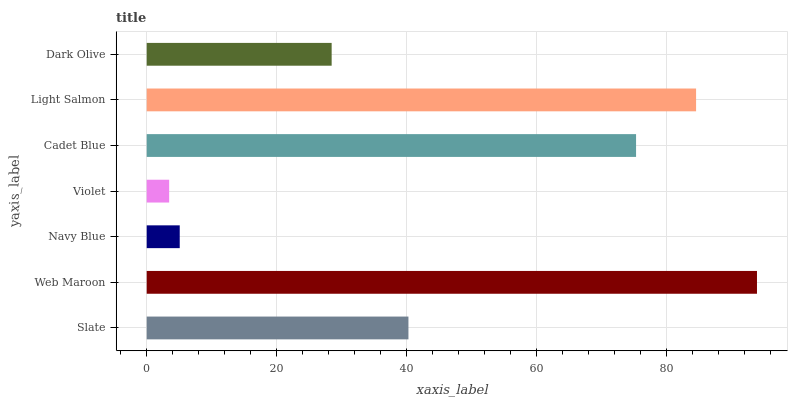Is Violet the minimum?
Answer yes or no. Yes. Is Web Maroon the maximum?
Answer yes or no. Yes. Is Navy Blue the minimum?
Answer yes or no. No. Is Navy Blue the maximum?
Answer yes or no. No. Is Web Maroon greater than Navy Blue?
Answer yes or no. Yes. Is Navy Blue less than Web Maroon?
Answer yes or no. Yes. Is Navy Blue greater than Web Maroon?
Answer yes or no. No. Is Web Maroon less than Navy Blue?
Answer yes or no. No. Is Slate the high median?
Answer yes or no. Yes. Is Slate the low median?
Answer yes or no. Yes. Is Violet the high median?
Answer yes or no. No. Is Violet the low median?
Answer yes or no. No. 